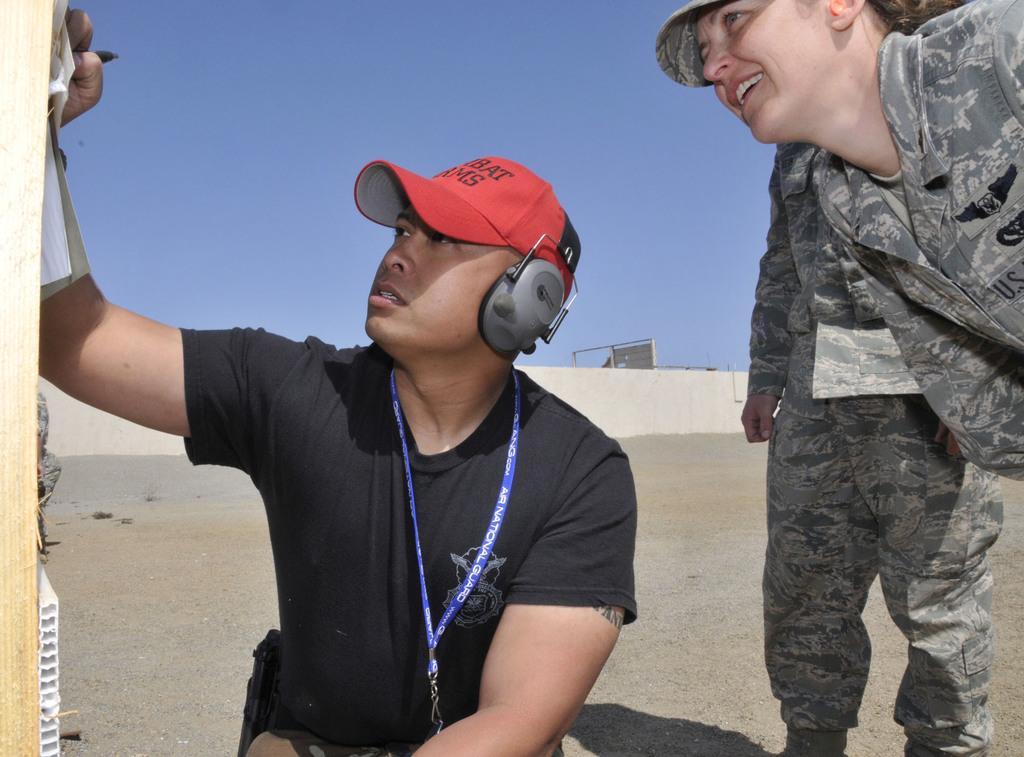In one or two sentences, can you explain what this image depicts? This is an outside view. Here I can see a person is sitting and two persons are wearing uniform and standing. These people are looking at the left side. On the left side there is a wooden object. The person who is sitting is holding a pen in the hand and writing something on the wooden object. In the background there is a wall. At the top of the image I can see the sky. This person is wearing a t-shirt and cap on the head. 